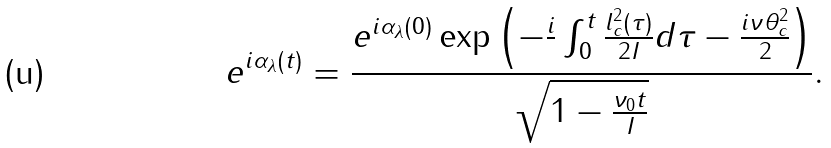Convert formula to latex. <formula><loc_0><loc_0><loc_500><loc_500>e ^ { i \alpha _ { \lambda } ( t ) } = \frac { e ^ { i \alpha _ { \lambda } ( 0 ) } \exp \left ( - \frac { i } { } \int ^ { t } _ { 0 } \frac { l ^ { 2 } _ { c } ( \tau ) } { 2 I } d \tau - \frac { i \nu \theta ^ { 2 } _ { c } } { 2 } \right ) } { \sqrt { 1 - \frac { \nu _ { 0 } t } { I } } } .</formula> 